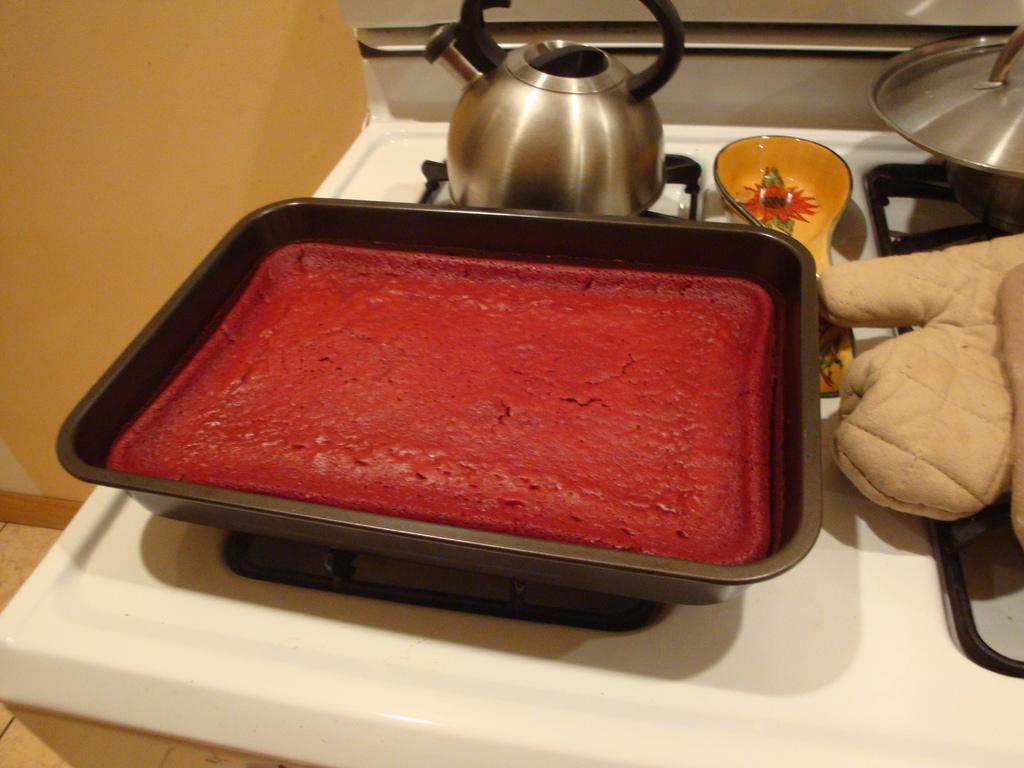How would you summarize this image in a sentence or two? In the image there is a baked cake in a tray on a table with tea kettle and some vessels behind it on the stove with a glove and in the back there is wall. 